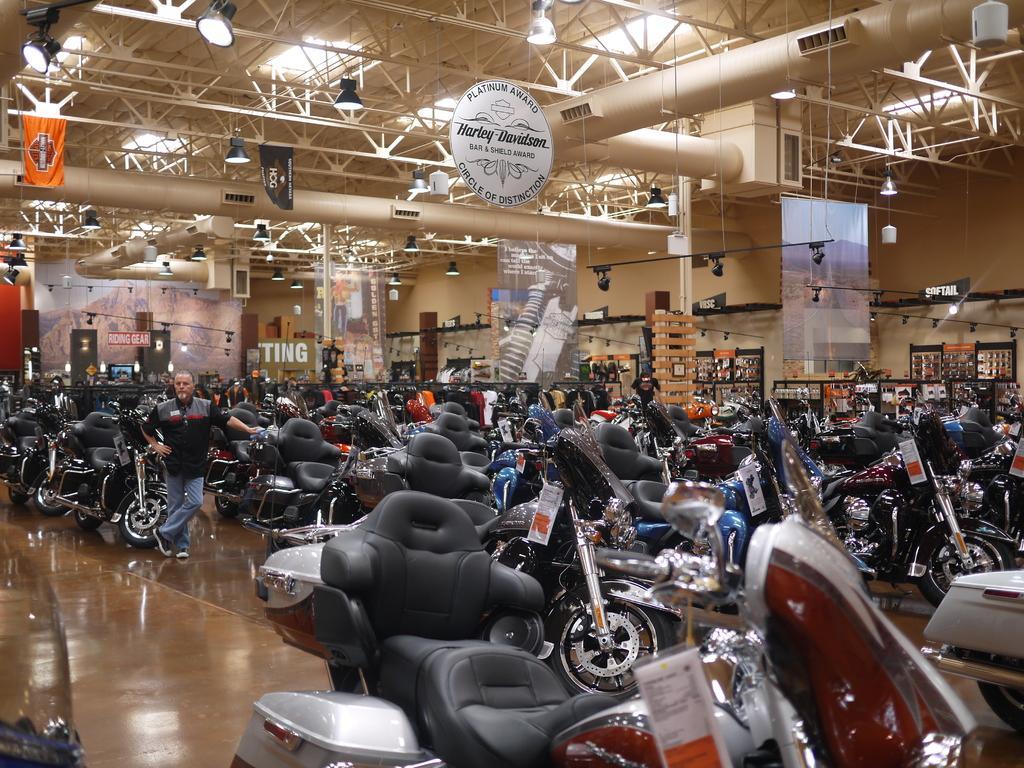How would you summarize this image in a sentence or two? In the picture I can see vehicles and people standing on the ground. In the background I can see banners, lights on the ceiling, boards and some other objects. 